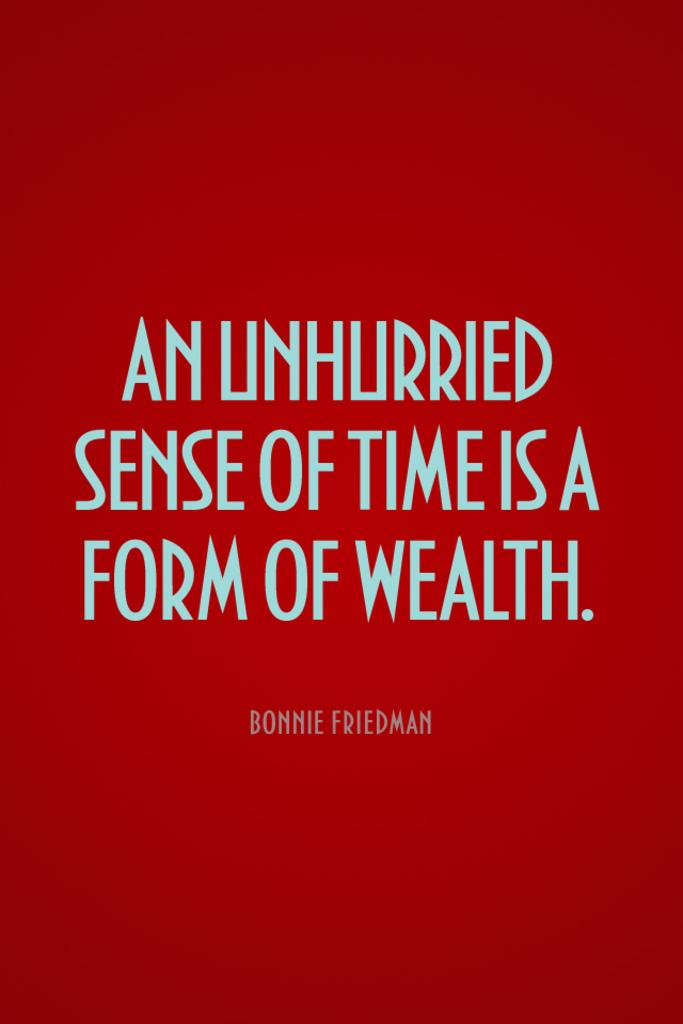<image>
Offer a succinct explanation of the picture presented. A red book titled An Unhurried Sense of Time is a Form of Wealth. 